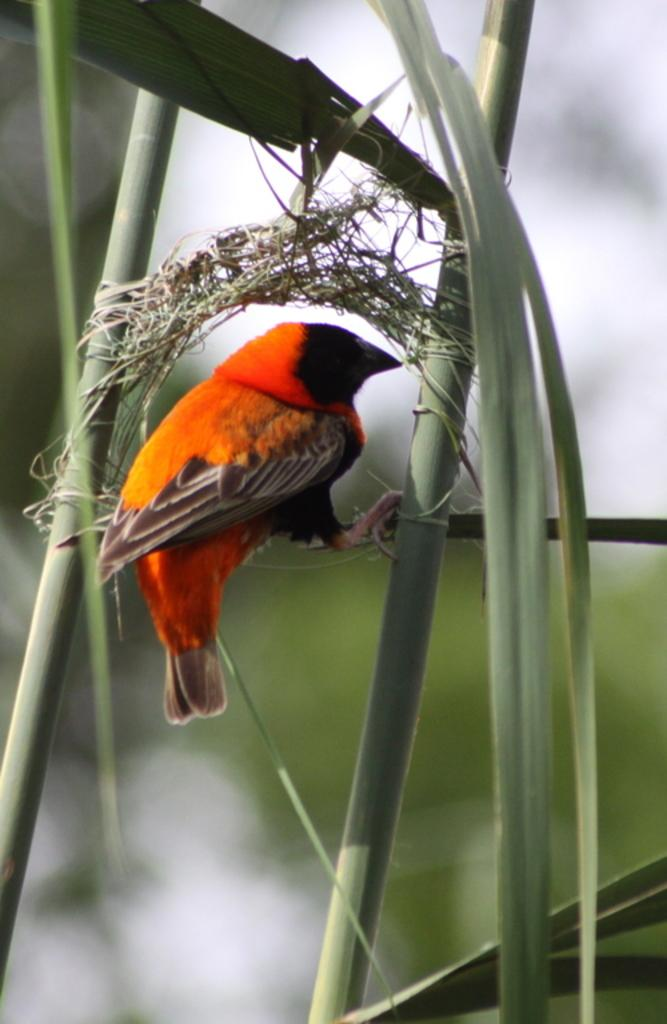What type of animal is present in the image? There is a bird in the image. What other living organisms can be seen in the image? There are plants in the image. Can you describe the background of the image? The background of the image is blurred. What scientific experiment is being conducted with the ghost in the image? There is no ghost present in the image, and no scientific experiment is being conducted. 